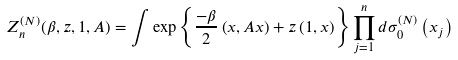Convert formula to latex. <formula><loc_0><loc_0><loc_500><loc_500>Z _ { n } ^ { ( N ) } ( \beta , z , 1 , A ) = \int \exp \left \{ \frac { - \beta } { 2 } \left ( x , A x \right ) + z \left ( 1 , x \right ) \right \} \prod _ { j = 1 } ^ { n } d \sigma _ { 0 } ^ { ( N ) } \left ( x _ { j } \right )</formula> 